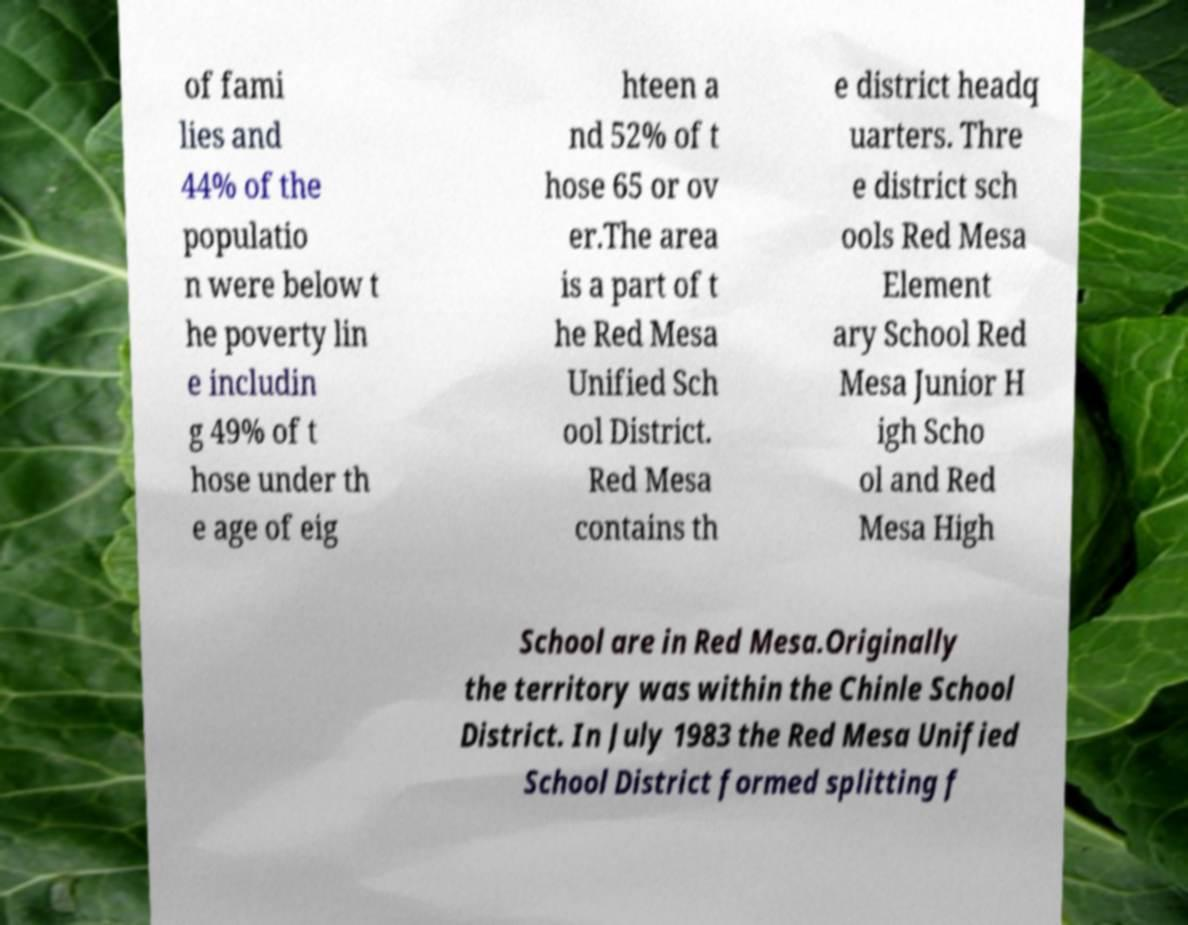I need the written content from this picture converted into text. Can you do that? of fami lies and 44% of the populatio n were below t he poverty lin e includin g 49% of t hose under th e age of eig hteen a nd 52% of t hose 65 or ov er.The area is a part of t he Red Mesa Unified Sch ool District. Red Mesa contains th e district headq uarters. Thre e district sch ools Red Mesa Element ary School Red Mesa Junior H igh Scho ol and Red Mesa High School are in Red Mesa.Originally the territory was within the Chinle School District. In July 1983 the Red Mesa Unified School District formed splitting f 